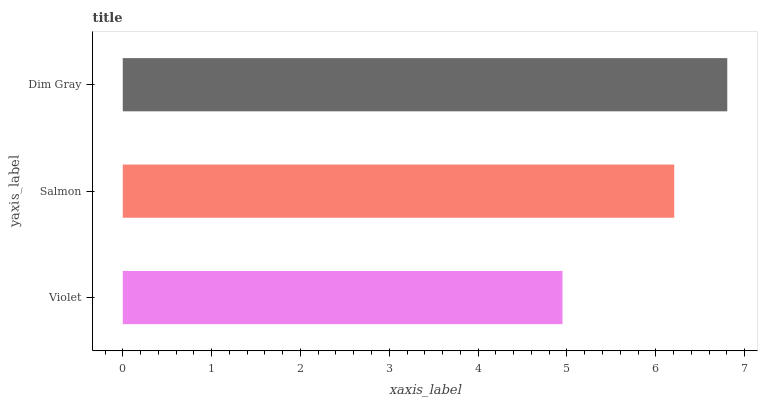Is Violet the minimum?
Answer yes or no. Yes. Is Dim Gray the maximum?
Answer yes or no. Yes. Is Salmon the minimum?
Answer yes or no. No. Is Salmon the maximum?
Answer yes or no. No. Is Salmon greater than Violet?
Answer yes or no. Yes. Is Violet less than Salmon?
Answer yes or no. Yes. Is Violet greater than Salmon?
Answer yes or no. No. Is Salmon less than Violet?
Answer yes or no. No. Is Salmon the high median?
Answer yes or no. Yes. Is Salmon the low median?
Answer yes or no. Yes. Is Dim Gray the high median?
Answer yes or no. No. Is Dim Gray the low median?
Answer yes or no. No. 